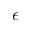<formula> <loc_0><loc_0><loc_500><loc_500>\epsilon</formula> 